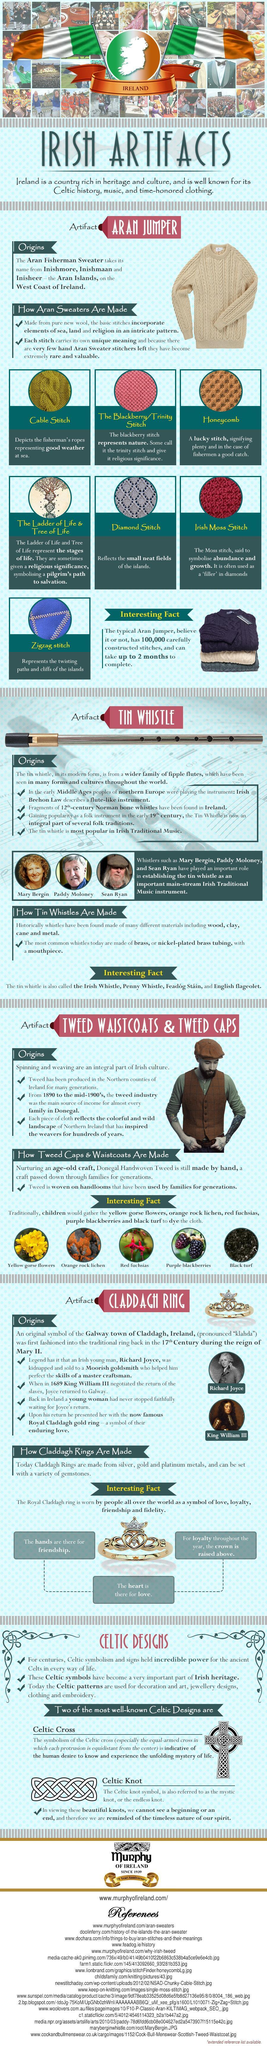Which stitch represents the twisting paths & cliffs of the islands?
Answer the question with a short phrase. Zigzag stitch Which stitch signifies the fishermen a good weather at sea? Cable Stitch Which stitch reflects the small neat fields of the islands? Diamond Stitch Which stitch signifies the fishermen a good catch? Honeycomb 